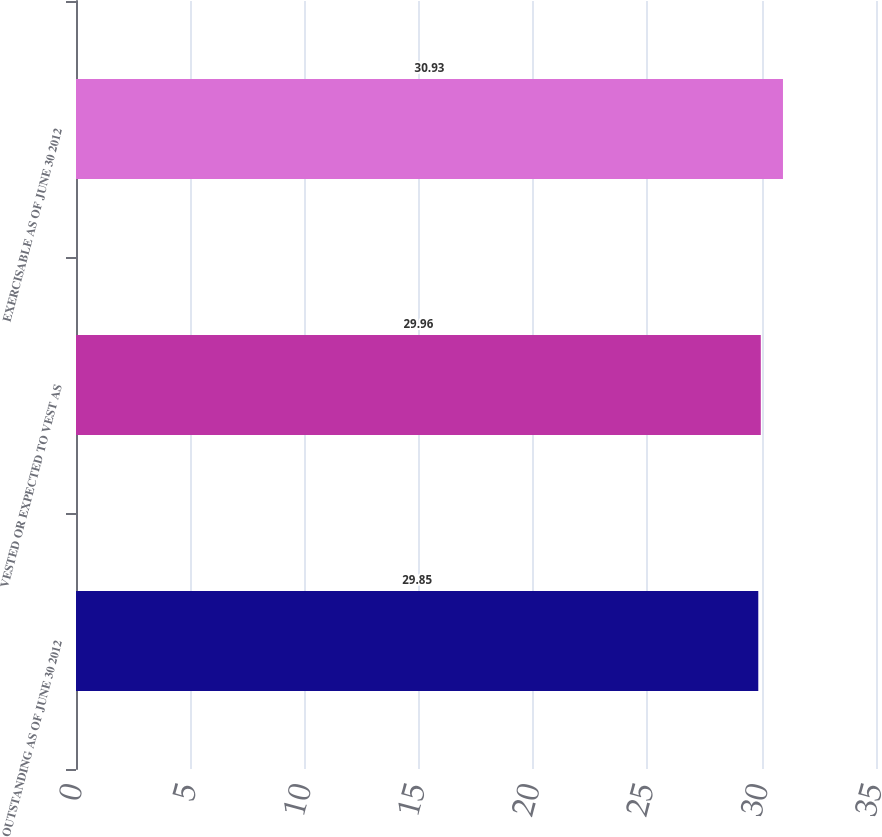Convert chart. <chart><loc_0><loc_0><loc_500><loc_500><bar_chart><fcel>OUTSTANDING AS OF JUNE 30 2012<fcel>VESTED OR EXPECTED TO VEST AS<fcel>EXERCISABLE AS OF JUNE 30 2012<nl><fcel>29.85<fcel>29.96<fcel>30.93<nl></chart> 